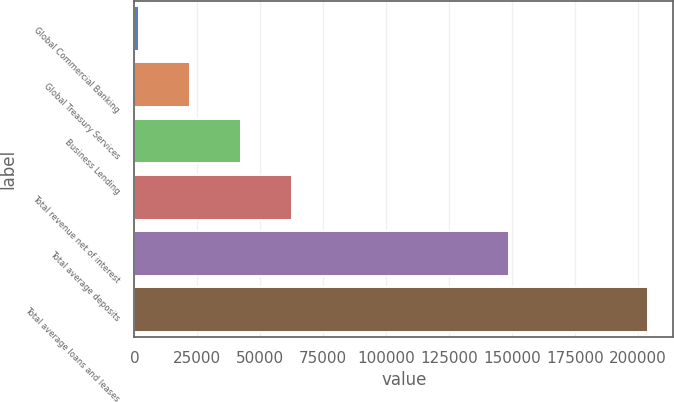<chart> <loc_0><loc_0><loc_500><loc_500><bar_chart><fcel>Global Commercial Banking<fcel>Global Treasury Services<fcel>Business Lending<fcel>Total revenue net of interest<fcel>Total average deposits<fcel>Total average loans and leases<nl><fcel>2010<fcel>22191.4<fcel>42372.8<fcel>62554.2<fcel>148638<fcel>203824<nl></chart> 